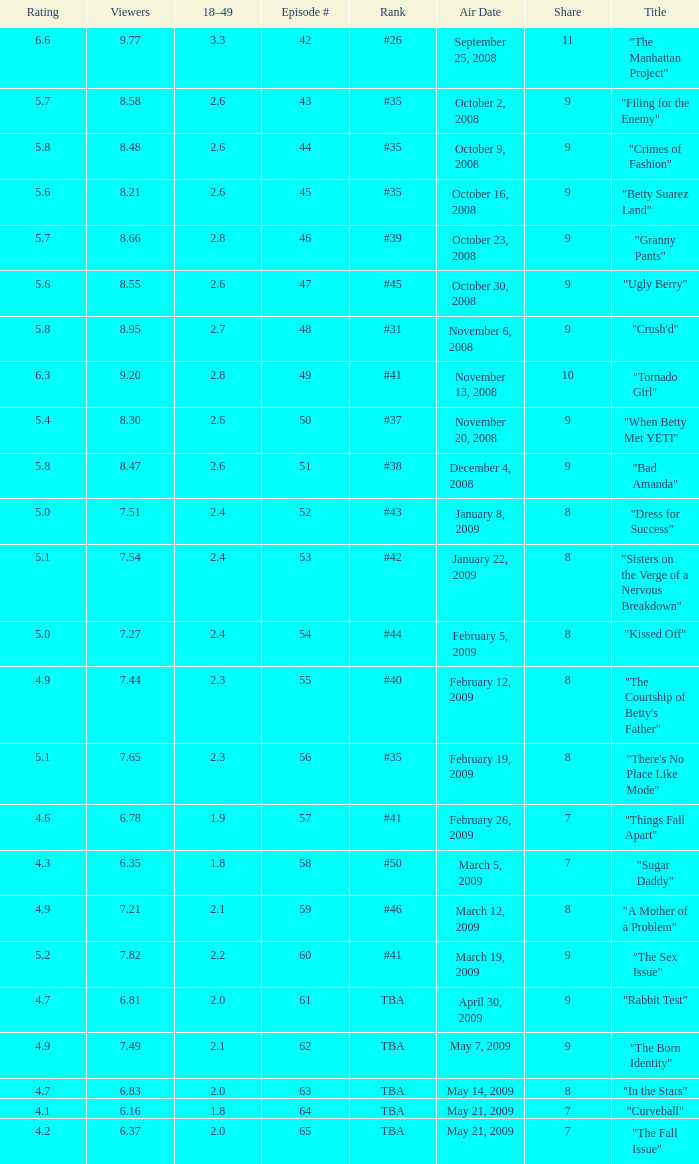What is the average Episode # with a 7 share and 18–49 is less than 2 and the Air Date of may 21, 2009? 64.0. 